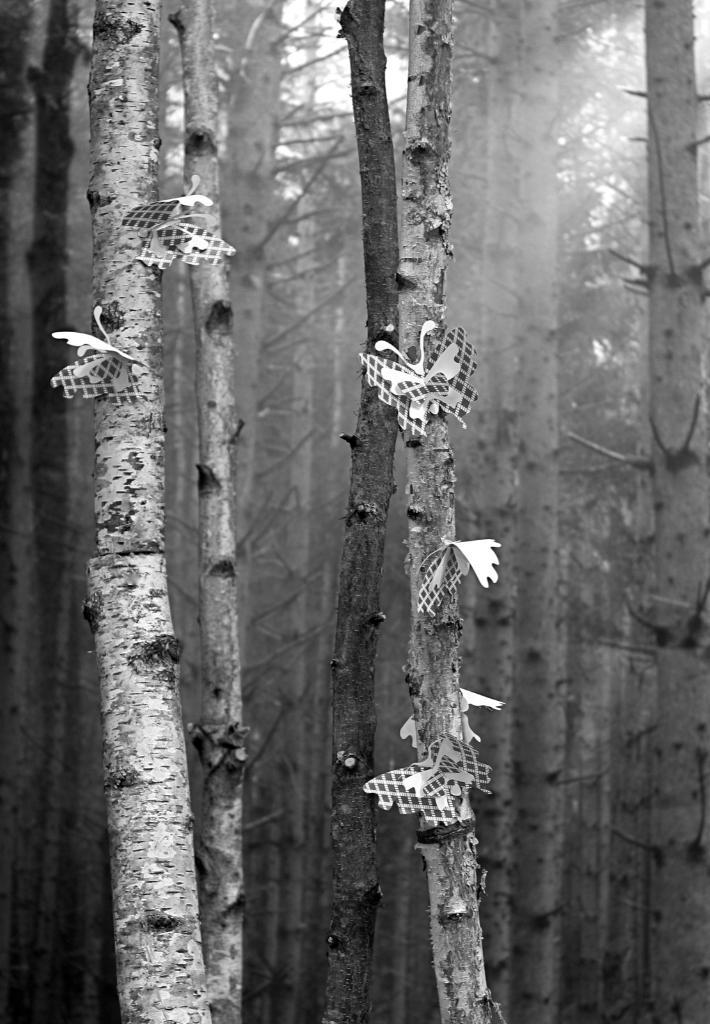What is the color scheme of the image? The image is black and white. What type of animals can be seen in the image? There are butterflies in the image. What other objects or features are present in the image? There are trees in the image. How many ladybugs can be seen in the image? There are no ladybugs present in the image; it features butterflies instead. What emotion might the butterflies be feeling in the image? The image does not convey emotions, so it is impossible to determine how the butterflies might be feeling. 